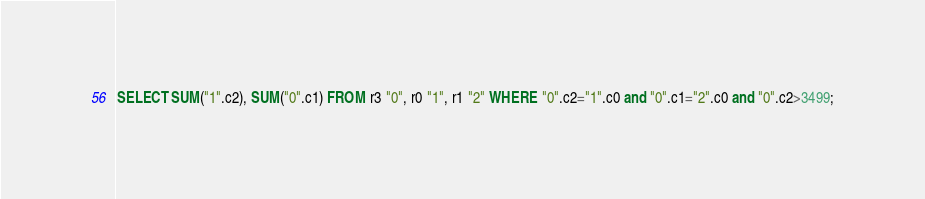<code> <loc_0><loc_0><loc_500><loc_500><_SQL_>SELECT SUM("1".c2), SUM("0".c1) FROM r3 "0", r0 "1", r1 "2" WHERE "0".c2="1".c0 and "0".c1="2".c0 and "0".c2>3499;</code> 